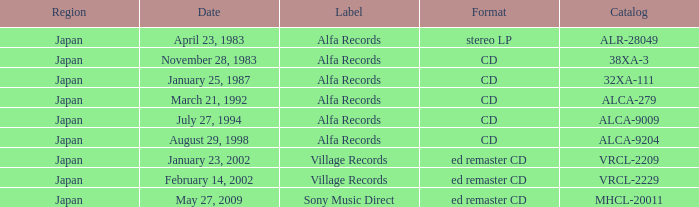Which mark is dated february 14, 2002? Village Records. 